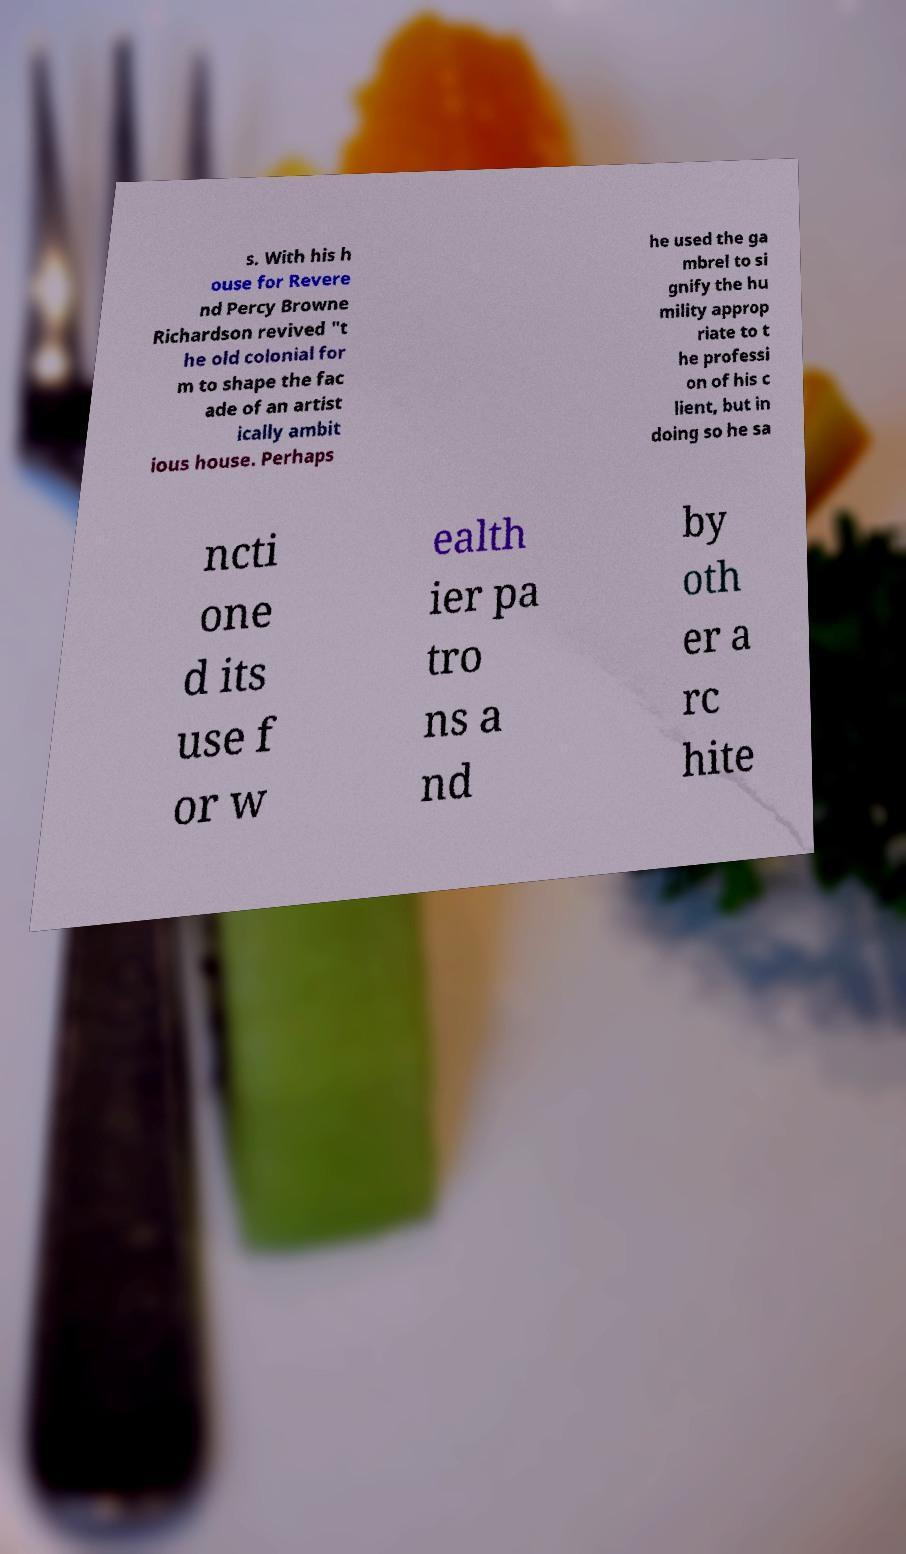There's text embedded in this image that I need extracted. Can you transcribe it verbatim? s. With his h ouse for Revere nd Percy Browne Richardson revived "t he old colonial for m to shape the fac ade of an artist ically ambit ious house. Perhaps he used the ga mbrel to si gnify the hu mility approp riate to t he professi on of his c lient, but in doing so he sa ncti one d its use f or w ealth ier pa tro ns a nd by oth er a rc hite 